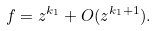<formula> <loc_0><loc_0><loc_500><loc_500>f = z ^ { k _ { 1 } } + O ( z ^ { k _ { 1 } + 1 } ) .</formula> 